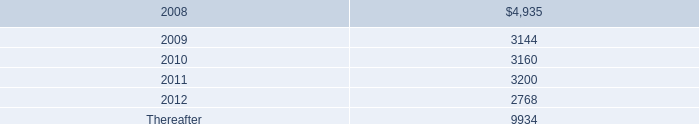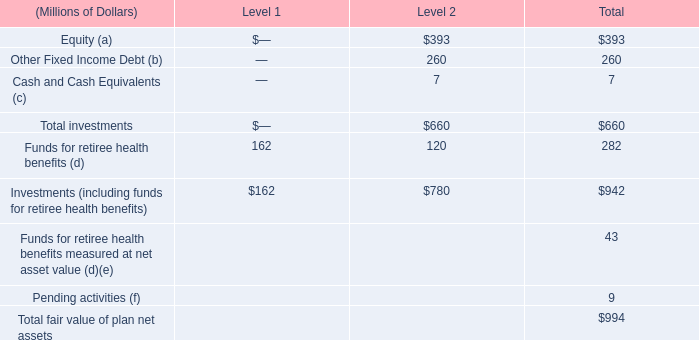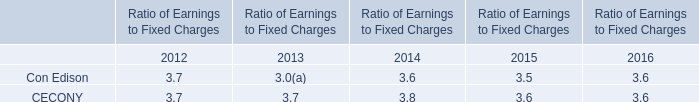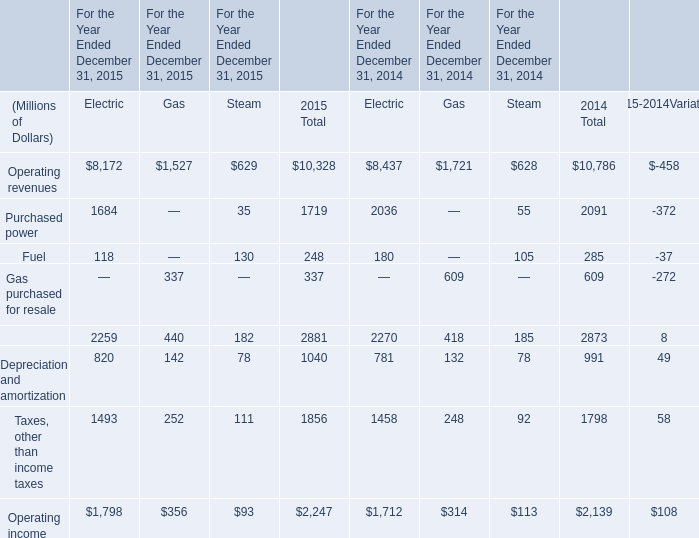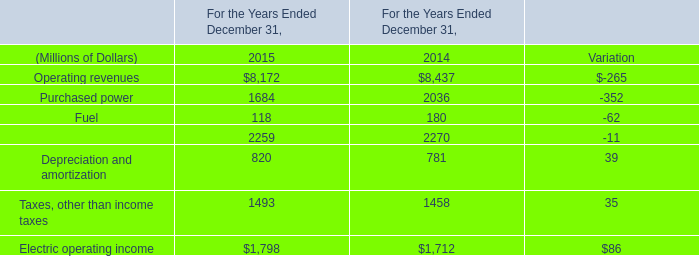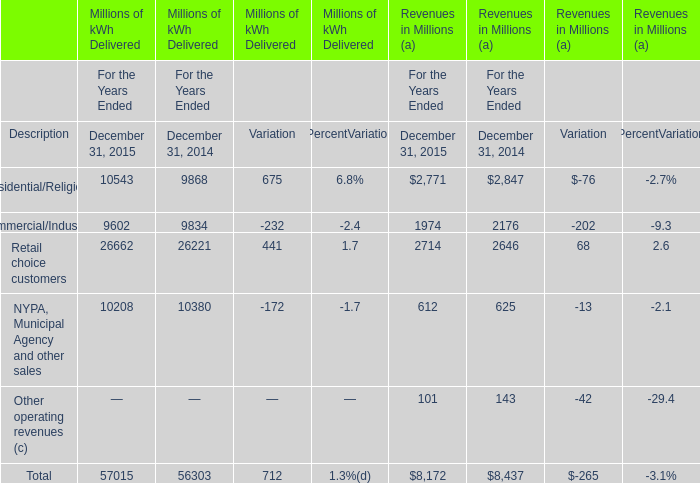What is the percentage of Residential/Religious of Millions of kWh Delivered in relation to the total in 2015? 
Computations: (10543 / 57015)
Answer: 0.18492. 